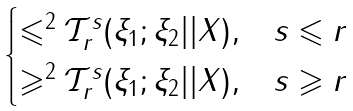Convert formula to latex. <formula><loc_0><loc_0><loc_500><loc_500>\begin{cases} { \leqslant ^ { 2 } { \mathcal { T } } _ { r } ^ { s } ( \xi _ { 1 } ; \xi _ { 2 } | | X ) , } & { s \leqslant r } \\ { \geqslant ^ { 2 } { \mathcal { T } } _ { r } ^ { s } ( \xi _ { 1 } ; \xi _ { 2 } | | X ) , } & { s \geqslant r } \\ \end{cases}</formula> 